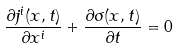Convert formula to latex. <formula><loc_0><loc_0><loc_500><loc_500>\frac { \partial j ^ { i } ( x , t ) } { \partial x ^ { i } } + \frac { \partial \sigma ( x , t ) } { \partial t } = 0</formula> 